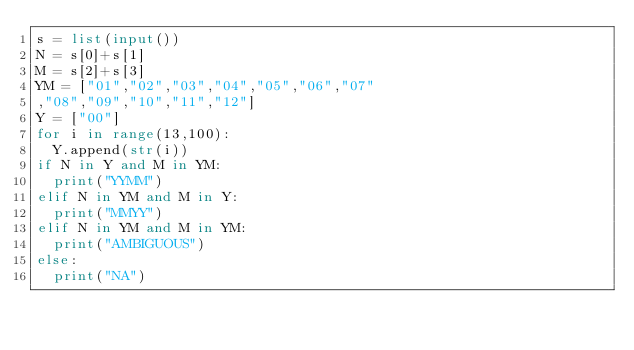Convert code to text. <code><loc_0><loc_0><loc_500><loc_500><_Python_>s = list(input())
N = s[0]+s[1]
M = s[2]+s[3]
YM = ["01","02","03","04","05","06","07"
,"08","09","10","11","12"]
Y = ["00"]
for i in range(13,100):
	Y.append(str(i))
if N in Y and M in YM:
	print("YYMM")
elif N in YM and M in Y:
	print("MMYY")
elif N in YM and M in YM:
	print("AMBIGUOUS")
else:
	print("NA")</code> 